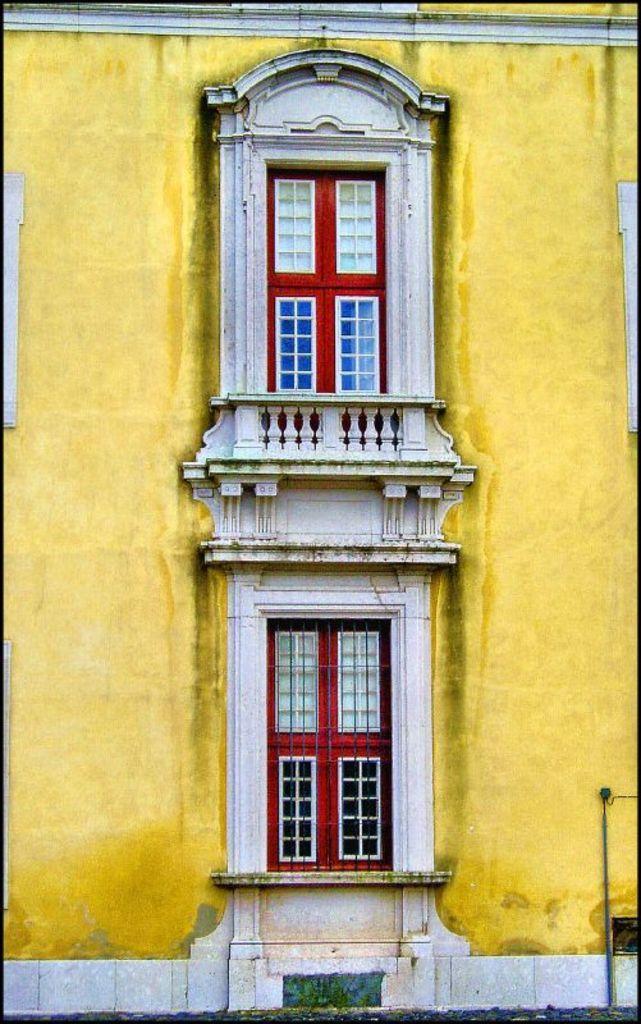Please provide a concise description of this image. In this picture we can see a building with yellow paint. we can see two doors here which is red in colour. 